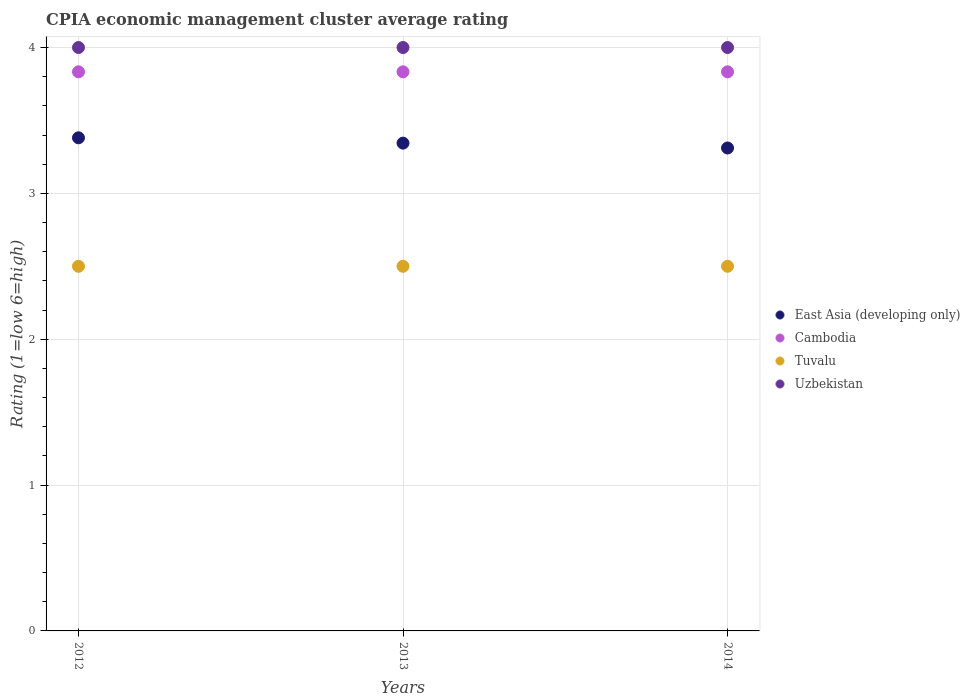Across all years, what is the maximum CPIA rating in Uzbekistan?
Give a very brief answer. 4. What is the total CPIA rating in East Asia (developing only) in the graph?
Give a very brief answer. 10.04. What is the difference between the CPIA rating in Cambodia in 2013 and that in 2014?
Give a very brief answer. 3.3333333289142786e-6. What is the difference between the CPIA rating in Uzbekistan in 2013 and the CPIA rating in East Asia (developing only) in 2012?
Make the answer very short. 0.62. What is the average CPIA rating in Uzbekistan per year?
Your response must be concise. 4. In the year 2012, what is the difference between the CPIA rating in Cambodia and CPIA rating in Tuvalu?
Provide a short and direct response. 1.33. In how many years, is the CPIA rating in Uzbekistan greater than 3.2?
Offer a terse response. 3. What is the ratio of the CPIA rating in Uzbekistan in 2012 to that in 2013?
Ensure brevity in your answer.  1. Is the CPIA rating in Uzbekistan in 2012 less than that in 2014?
Your answer should be very brief. No. Is the difference between the CPIA rating in Cambodia in 2012 and 2014 greater than the difference between the CPIA rating in Tuvalu in 2012 and 2014?
Your response must be concise. Yes. What is the difference between the highest and the second highest CPIA rating in Cambodia?
Offer a very short reply. 0. What is the difference between the highest and the lowest CPIA rating in Cambodia?
Offer a very short reply. 3.3333333289142786e-6. In how many years, is the CPIA rating in Uzbekistan greater than the average CPIA rating in Uzbekistan taken over all years?
Offer a terse response. 0. Is it the case that in every year, the sum of the CPIA rating in Cambodia and CPIA rating in Uzbekistan  is greater than the CPIA rating in East Asia (developing only)?
Provide a succinct answer. Yes. Is the CPIA rating in Cambodia strictly greater than the CPIA rating in Tuvalu over the years?
Make the answer very short. Yes. Is the CPIA rating in Cambodia strictly less than the CPIA rating in Uzbekistan over the years?
Provide a short and direct response. Yes. How many dotlines are there?
Your answer should be compact. 4. Does the graph contain any zero values?
Your response must be concise. No. Does the graph contain grids?
Your answer should be compact. Yes. What is the title of the graph?
Offer a terse response. CPIA economic management cluster average rating. Does "Uzbekistan" appear as one of the legend labels in the graph?
Give a very brief answer. Yes. What is the Rating (1=low 6=high) in East Asia (developing only) in 2012?
Your response must be concise. 3.38. What is the Rating (1=low 6=high) in Cambodia in 2012?
Offer a terse response. 3.83. What is the Rating (1=low 6=high) in Tuvalu in 2012?
Your answer should be compact. 2.5. What is the Rating (1=low 6=high) of Uzbekistan in 2012?
Provide a short and direct response. 4. What is the Rating (1=low 6=high) in East Asia (developing only) in 2013?
Give a very brief answer. 3.34. What is the Rating (1=low 6=high) of Cambodia in 2013?
Offer a terse response. 3.83. What is the Rating (1=low 6=high) of East Asia (developing only) in 2014?
Your answer should be very brief. 3.31. What is the Rating (1=low 6=high) of Cambodia in 2014?
Ensure brevity in your answer.  3.83. What is the Rating (1=low 6=high) of Tuvalu in 2014?
Ensure brevity in your answer.  2.5. Across all years, what is the maximum Rating (1=low 6=high) of East Asia (developing only)?
Make the answer very short. 3.38. Across all years, what is the maximum Rating (1=low 6=high) of Cambodia?
Provide a succinct answer. 3.83. Across all years, what is the minimum Rating (1=low 6=high) of East Asia (developing only)?
Offer a terse response. 3.31. Across all years, what is the minimum Rating (1=low 6=high) in Cambodia?
Provide a succinct answer. 3.83. What is the total Rating (1=low 6=high) of East Asia (developing only) in the graph?
Your answer should be compact. 10.04. What is the total Rating (1=low 6=high) in Cambodia in the graph?
Your answer should be very brief. 11.5. What is the total Rating (1=low 6=high) of Tuvalu in the graph?
Your answer should be very brief. 7.5. What is the difference between the Rating (1=low 6=high) in East Asia (developing only) in 2012 and that in 2013?
Offer a very short reply. 0.04. What is the difference between the Rating (1=low 6=high) of Tuvalu in 2012 and that in 2013?
Your response must be concise. 0. What is the difference between the Rating (1=low 6=high) in Uzbekistan in 2012 and that in 2013?
Your answer should be very brief. 0. What is the difference between the Rating (1=low 6=high) in East Asia (developing only) in 2012 and that in 2014?
Your response must be concise. 0.07. What is the difference between the Rating (1=low 6=high) in Tuvalu in 2012 and that in 2014?
Your response must be concise. 0. What is the difference between the Rating (1=low 6=high) in East Asia (developing only) in 2013 and that in 2014?
Your answer should be compact. 0.03. What is the difference between the Rating (1=low 6=high) of Uzbekistan in 2013 and that in 2014?
Keep it short and to the point. 0. What is the difference between the Rating (1=low 6=high) of East Asia (developing only) in 2012 and the Rating (1=low 6=high) of Cambodia in 2013?
Your answer should be very brief. -0.45. What is the difference between the Rating (1=low 6=high) of East Asia (developing only) in 2012 and the Rating (1=low 6=high) of Tuvalu in 2013?
Your answer should be compact. 0.88. What is the difference between the Rating (1=low 6=high) of East Asia (developing only) in 2012 and the Rating (1=low 6=high) of Uzbekistan in 2013?
Give a very brief answer. -0.62. What is the difference between the Rating (1=low 6=high) in Cambodia in 2012 and the Rating (1=low 6=high) in Uzbekistan in 2013?
Provide a succinct answer. -0.17. What is the difference between the Rating (1=low 6=high) of East Asia (developing only) in 2012 and the Rating (1=low 6=high) of Cambodia in 2014?
Your answer should be very brief. -0.45. What is the difference between the Rating (1=low 6=high) of East Asia (developing only) in 2012 and the Rating (1=low 6=high) of Tuvalu in 2014?
Keep it short and to the point. 0.88. What is the difference between the Rating (1=low 6=high) of East Asia (developing only) in 2012 and the Rating (1=low 6=high) of Uzbekistan in 2014?
Provide a short and direct response. -0.62. What is the difference between the Rating (1=low 6=high) in Cambodia in 2012 and the Rating (1=low 6=high) in Uzbekistan in 2014?
Make the answer very short. -0.17. What is the difference between the Rating (1=low 6=high) in East Asia (developing only) in 2013 and the Rating (1=low 6=high) in Cambodia in 2014?
Give a very brief answer. -0.49. What is the difference between the Rating (1=low 6=high) of East Asia (developing only) in 2013 and the Rating (1=low 6=high) of Tuvalu in 2014?
Give a very brief answer. 0.84. What is the difference between the Rating (1=low 6=high) in East Asia (developing only) in 2013 and the Rating (1=low 6=high) in Uzbekistan in 2014?
Offer a terse response. -0.66. What is the difference between the Rating (1=low 6=high) in Cambodia in 2013 and the Rating (1=low 6=high) in Tuvalu in 2014?
Your answer should be very brief. 1.33. What is the difference between the Rating (1=low 6=high) in Cambodia in 2013 and the Rating (1=low 6=high) in Uzbekistan in 2014?
Ensure brevity in your answer.  -0.17. What is the average Rating (1=low 6=high) in East Asia (developing only) per year?
Give a very brief answer. 3.35. What is the average Rating (1=low 6=high) in Cambodia per year?
Your answer should be very brief. 3.83. What is the average Rating (1=low 6=high) of Tuvalu per year?
Offer a very short reply. 2.5. What is the average Rating (1=low 6=high) of Uzbekistan per year?
Offer a terse response. 4. In the year 2012, what is the difference between the Rating (1=low 6=high) of East Asia (developing only) and Rating (1=low 6=high) of Cambodia?
Keep it short and to the point. -0.45. In the year 2012, what is the difference between the Rating (1=low 6=high) in East Asia (developing only) and Rating (1=low 6=high) in Tuvalu?
Your answer should be very brief. 0.88. In the year 2012, what is the difference between the Rating (1=low 6=high) in East Asia (developing only) and Rating (1=low 6=high) in Uzbekistan?
Give a very brief answer. -0.62. In the year 2012, what is the difference between the Rating (1=low 6=high) of Cambodia and Rating (1=low 6=high) of Tuvalu?
Your response must be concise. 1.33. In the year 2012, what is the difference between the Rating (1=low 6=high) in Cambodia and Rating (1=low 6=high) in Uzbekistan?
Give a very brief answer. -0.17. In the year 2012, what is the difference between the Rating (1=low 6=high) in Tuvalu and Rating (1=low 6=high) in Uzbekistan?
Offer a very short reply. -1.5. In the year 2013, what is the difference between the Rating (1=low 6=high) of East Asia (developing only) and Rating (1=low 6=high) of Cambodia?
Give a very brief answer. -0.49. In the year 2013, what is the difference between the Rating (1=low 6=high) in East Asia (developing only) and Rating (1=low 6=high) in Tuvalu?
Your answer should be very brief. 0.84. In the year 2013, what is the difference between the Rating (1=low 6=high) in East Asia (developing only) and Rating (1=low 6=high) in Uzbekistan?
Offer a very short reply. -0.66. In the year 2013, what is the difference between the Rating (1=low 6=high) in Cambodia and Rating (1=low 6=high) in Tuvalu?
Your answer should be compact. 1.33. In the year 2013, what is the difference between the Rating (1=low 6=high) of Cambodia and Rating (1=low 6=high) of Uzbekistan?
Your answer should be compact. -0.17. In the year 2014, what is the difference between the Rating (1=low 6=high) in East Asia (developing only) and Rating (1=low 6=high) in Cambodia?
Provide a succinct answer. -0.52. In the year 2014, what is the difference between the Rating (1=low 6=high) in East Asia (developing only) and Rating (1=low 6=high) in Tuvalu?
Your answer should be very brief. 0.81. In the year 2014, what is the difference between the Rating (1=low 6=high) in East Asia (developing only) and Rating (1=low 6=high) in Uzbekistan?
Your answer should be compact. -0.69. What is the ratio of the Rating (1=low 6=high) of East Asia (developing only) in 2012 to that in 2013?
Provide a succinct answer. 1.01. What is the ratio of the Rating (1=low 6=high) in Tuvalu in 2012 to that in 2013?
Your response must be concise. 1. What is the ratio of the Rating (1=low 6=high) of Uzbekistan in 2012 to that in 2013?
Offer a terse response. 1. What is the ratio of the Rating (1=low 6=high) of East Asia (developing only) in 2012 to that in 2014?
Give a very brief answer. 1.02. What is the ratio of the Rating (1=low 6=high) of Uzbekistan in 2012 to that in 2014?
Your response must be concise. 1. What is the ratio of the Rating (1=low 6=high) of East Asia (developing only) in 2013 to that in 2014?
Your answer should be very brief. 1.01. What is the difference between the highest and the second highest Rating (1=low 6=high) of East Asia (developing only)?
Make the answer very short. 0.04. What is the difference between the highest and the second highest Rating (1=low 6=high) in Cambodia?
Provide a short and direct response. 0. What is the difference between the highest and the second highest Rating (1=low 6=high) in Uzbekistan?
Provide a succinct answer. 0. What is the difference between the highest and the lowest Rating (1=low 6=high) of East Asia (developing only)?
Your response must be concise. 0.07. What is the difference between the highest and the lowest Rating (1=low 6=high) in Cambodia?
Offer a very short reply. 0. 